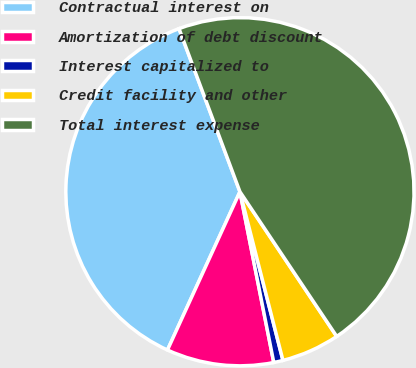<chart> <loc_0><loc_0><loc_500><loc_500><pie_chart><fcel>Contractual interest on<fcel>Amortization of debt discount<fcel>Interest capitalized to<fcel>Credit facility and other<fcel>Total interest expense<nl><fcel>37.48%<fcel>9.95%<fcel>0.86%<fcel>5.41%<fcel>46.31%<nl></chart> 